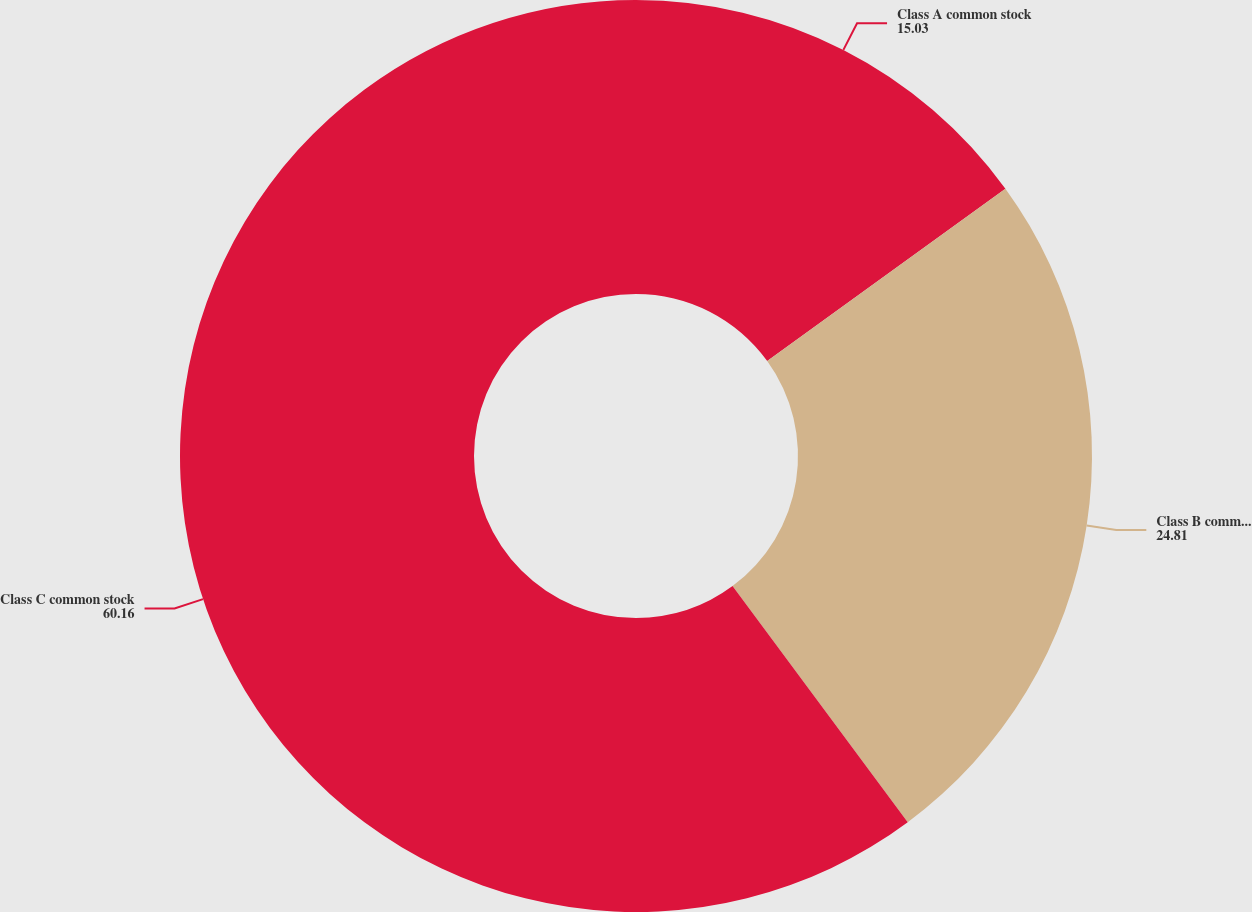Convert chart to OTSL. <chart><loc_0><loc_0><loc_500><loc_500><pie_chart><fcel>Class A common stock<fcel>Class B common stock<fcel>Class C common stock<nl><fcel>15.03%<fcel>24.81%<fcel>60.16%<nl></chart> 